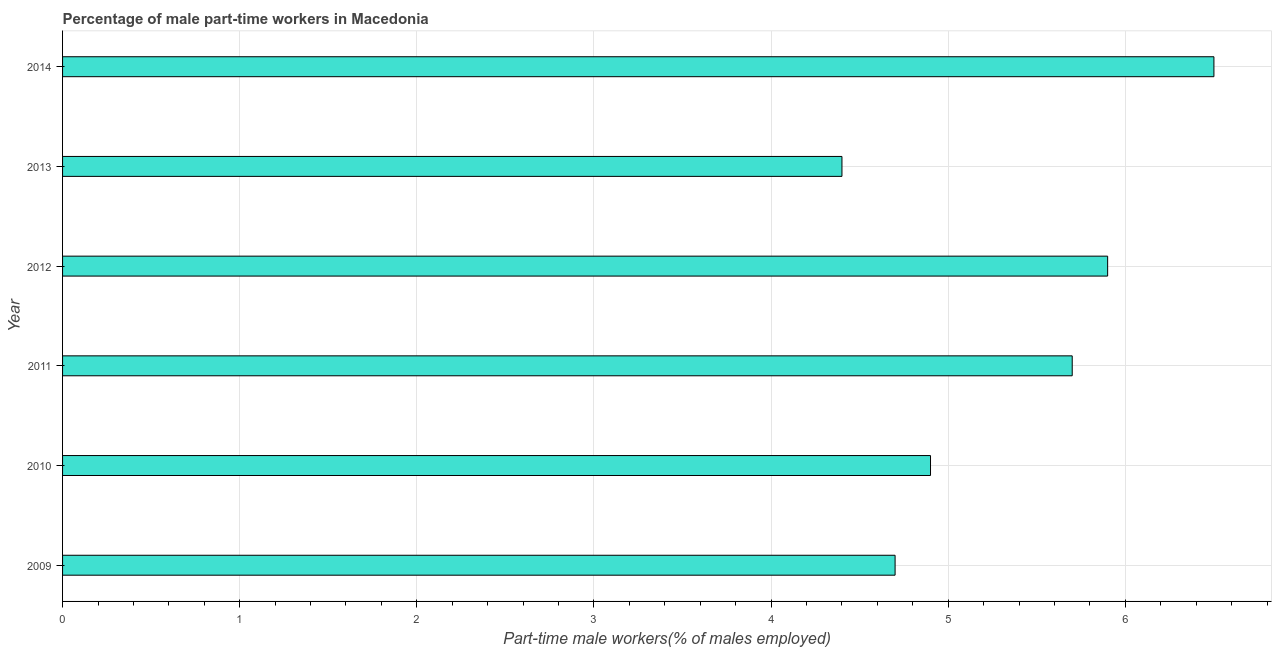Does the graph contain grids?
Your response must be concise. Yes. What is the title of the graph?
Provide a succinct answer. Percentage of male part-time workers in Macedonia. What is the label or title of the X-axis?
Your response must be concise. Part-time male workers(% of males employed). What is the percentage of part-time male workers in 2012?
Offer a terse response. 5.9. Across all years, what is the minimum percentage of part-time male workers?
Your response must be concise. 4.4. What is the sum of the percentage of part-time male workers?
Your answer should be compact. 32.1. What is the average percentage of part-time male workers per year?
Your response must be concise. 5.35. What is the median percentage of part-time male workers?
Make the answer very short. 5.3. What is the ratio of the percentage of part-time male workers in 2010 to that in 2011?
Give a very brief answer. 0.86. What is the difference between the highest and the second highest percentage of part-time male workers?
Provide a succinct answer. 0.6. How many bars are there?
Offer a terse response. 6. Are the values on the major ticks of X-axis written in scientific E-notation?
Offer a very short reply. No. What is the Part-time male workers(% of males employed) of 2009?
Offer a terse response. 4.7. What is the Part-time male workers(% of males employed) in 2010?
Give a very brief answer. 4.9. What is the Part-time male workers(% of males employed) of 2011?
Give a very brief answer. 5.7. What is the Part-time male workers(% of males employed) of 2012?
Provide a succinct answer. 5.9. What is the Part-time male workers(% of males employed) in 2013?
Offer a very short reply. 4.4. What is the Part-time male workers(% of males employed) in 2014?
Offer a very short reply. 6.5. What is the difference between the Part-time male workers(% of males employed) in 2009 and 2010?
Offer a very short reply. -0.2. What is the difference between the Part-time male workers(% of males employed) in 2009 and 2013?
Your response must be concise. 0.3. What is the difference between the Part-time male workers(% of males employed) in 2011 and 2014?
Give a very brief answer. -0.8. What is the difference between the Part-time male workers(% of males employed) in 2012 and 2014?
Offer a terse response. -0.6. What is the ratio of the Part-time male workers(% of males employed) in 2009 to that in 2011?
Your response must be concise. 0.82. What is the ratio of the Part-time male workers(% of males employed) in 2009 to that in 2012?
Your response must be concise. 0.8. What is the ratio of the Part-time male workers(% of males employed) in 2009 to that in 2013?
Your answer should be compact. 1.07. What is the ratio of the Part-time male workers(% of males employed) in 2009 to that in 2014?
Provide a succinct answer. 0.72. What is the ratio of the Part-time male workers(% of males employed) in 2010 to that in 2011?
Your response must be concise. 0.86. What is the ratio of the Part-time male workers(% of males employed) in 2010 to that in 2012?
Offer a terse response. 0.83. What is the ratio of the Part-time male workers(% of males employed) in 2010 to that in 2013?
Ensure brevity in your answer.  1.11. What is the ratio of the Part-time male workers(% of males employed) in 2010 to that in 2014?
Make the answer very short. 0.75. What is the ratio of the Part-time male workers(% of males employed) in 2011 to that in 2013?
Keep it short and to the point. 1.29. What is the ratio of the Part-time male workers(% of males employed) in 2011 to that in 2014?
Provide a short and direct response. 0.88. What is the ratio of the Part-time male workers(% of males employed) in 2012 to that in 2013?
Ensure brevity in your answer.  1.34. What is the ratio of the Part-time male workers(% of males employed) in 2012 to that in 2014?
Offer a very short reply. 0.91. What is the ratio of the Part-time male workers(% of males employed) in 2013 to that in 2014?
Keep it short and to the point. 0.68. 